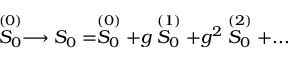Convert formula to latex. <formula><loc_0><loc_0><loc_500><loc_500>\stackrel { ( 0 ) } { S _ { 0 } } \longrightarrow S _ { 0 } = \stackrel { ( 0 ) } { S _ { 0 } } + g \stackrel { ( 1 ) } { S _ { 0 } } + g ^ { 2 } \stackrel { ( 2 ) } { S _ { 0 } } + \dots</formula> 